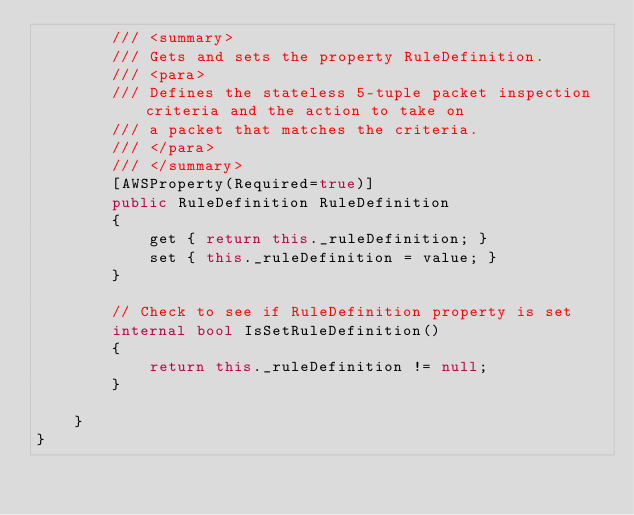Convert code to text. <code><loc_0><loc_0><loc_500><loc_500><_C#_>        /// <summary>
        /// Gets and sets the property RuleDefinition. 
        /// <para>
        /// Defines the stateless 5-tuple packet inspection criteria and the action to take on
        /// a packet that matches the criteria. 
        /// </para>
        /// </summary>
        [AWSProperty(Required=true)]
        public RuleDefinition RuleDefinition
        {
            get { return this._ruleDefinition; }
            set { this._ruleDefinition = value; }
        }

        // Check to see if RuleDefinition property is set
        internal bool IsSetRuleDefinition()
        {
            return this._ruleDefinition != null;
        }

    }
}</code> 